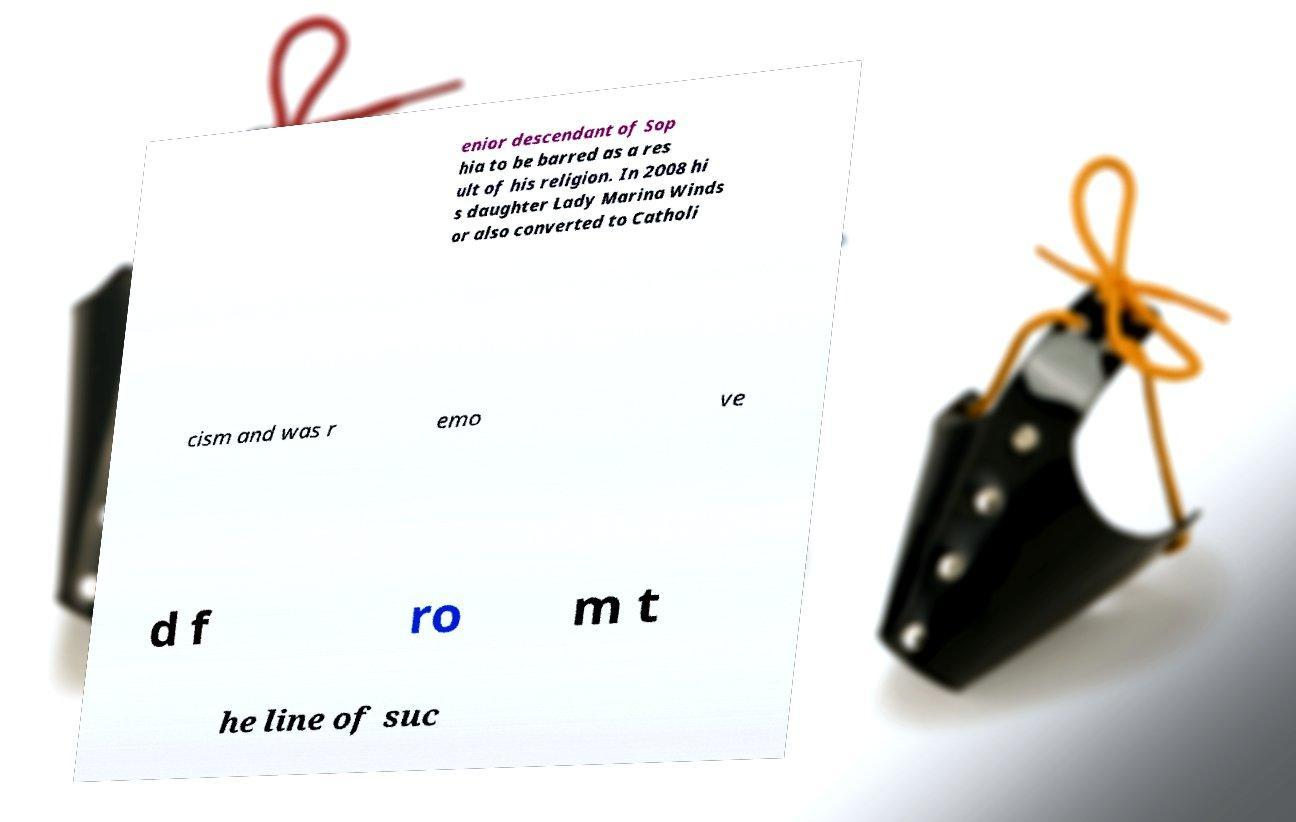I need the written content from this picture converted into text. Can you do that? enior descendant of Sop hia to be barred as a res ult of his religion. In 2008 hi s daughter Lady Marina Winds or also converted to Catholi cism and was r emo ve d f ro m t he line of suc 